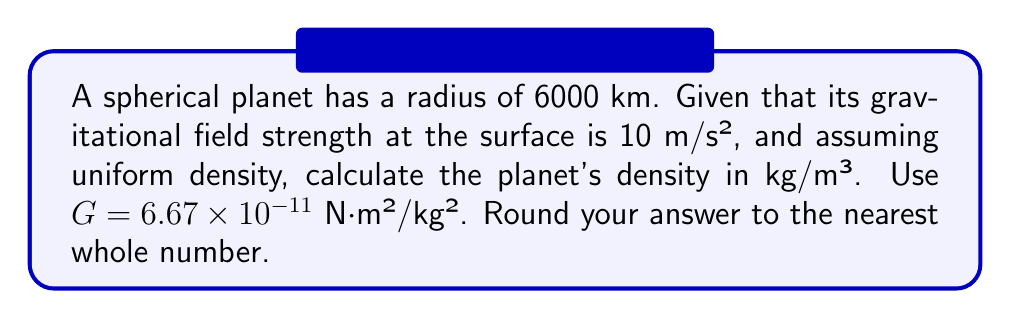Give your solution to this math problem. Let's approach this step-by-step:

1) The gravitational field strength $g$ at the surface of a uniform spherical planet is given by:

   $$g = \frac{GM}{R^2}$$

   where $G$ is the gravitational constant, $M$ is the mass of the planet, and $R$ is the radius.

2) We know $g = 10$ m/s², $R = 6000$ km = $6 \times 10^6$ m, and $G = 6.67 \times 10^{-11}$ N⋅m²/kg².

3) Rearranging the equation to solve for $M$:

   $$M = \frac{gR^2}{G}$$

4) Substituting the values:

   $$M = \frac{10 \times (6 \times 10^6)^2}{6.67 \times 10^{-11}} = 5.4 \times 10^{24}$$ kg

5) The density $\rho$ is mass divided by volume. For a sphere, volume $V = \frac{4}{3}\pi R^3$. So:

   $$\rho = \frac{M}{V} = \frac{M}{\frac{4}{3}\pi R^3}$$

6) Substituting the values:

   $$\rho = \frac{5.4 \times 10^{24}}{\frac{4}{3}\pi (6 \times 10^6)^3} = 5386$$ kg/m³

7) Rounding to the nearest whole number: 5386 kg/m³
Answer: 5386 kg/m³ 